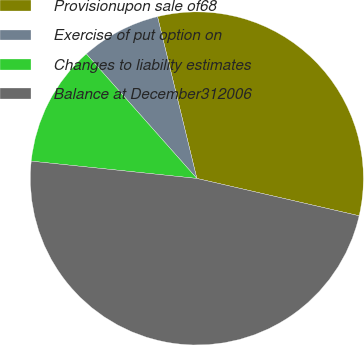Convert chart to OTSL. <chart><loc_0><loc_0><loc_500><loc_500><pie_chart><fcel>Provisionupon sale of68<fcel>Exercise of put option on<fcel>Changes to liability estimates<fcel>Balance at December312006<nl><fcel>32.4%<fcel>7.76%<fcel>11.79%<fcel>48.06%<nl></chart> 